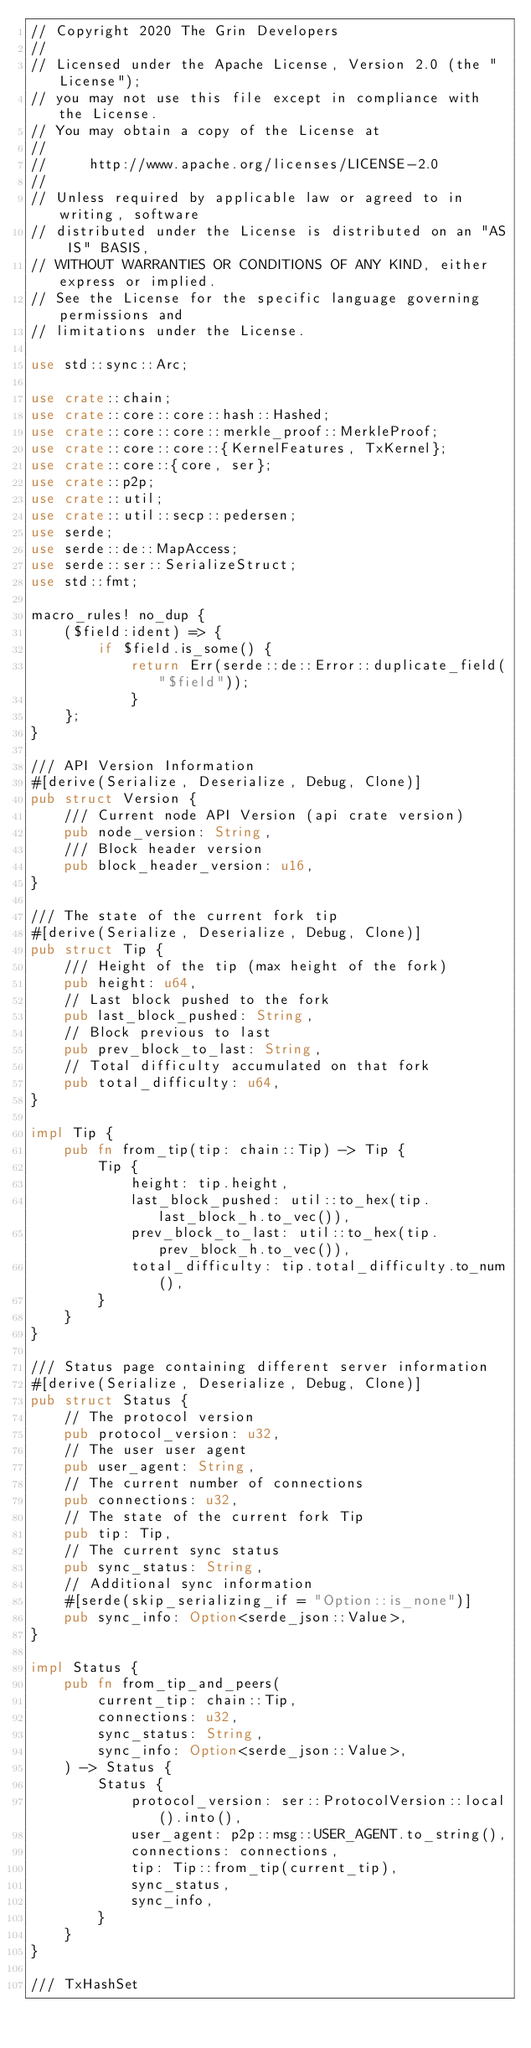Convert code to text. <code><loc_0><loc_0><loc_500><loc_500><_Rust_>// Copyright 2020 The Grin Developers
//
// Licensed under the Apache License, Version 2.0 (the "License");
// you may not use this file except in compliance with the License.
// You may obtain a copy of the License at
//
//     http://www.apache.org/licenses/LICENSE-2.0
//
// Unless required by applicable law or agreed to in writing, software
// distributed under the License is distributed on an "AS IS" BASIS,
// WITHOUT WARRANTIES OR CONDITIONS OF ANY KIND, either express or implied.
// See the License for the specific language governing permissions and
// limitations under the License.

use std::sync::Arc;

use crate::chain;
use crate::core::core::hash::Hashed;
use crate::core::core::merkle_proof::MerkleProof;
use crate::core::core::{KernelFeatures, TxKernel};
use crate::core::{core, ser};
use crate::p2p;
use crate::util;
use crate::util::secp::pedersen;
use serde;
use serde::de::MapAccess;
use serde::ser::SerializeStruct;
use std::fmt;

macro_rules! no_dup {
	($field:ident) => {
		if $field.is_some() {
			return Err(serde::de::Error::duplicate_field("$field"));
			}
	};
}

/// API Version Information
#[derive(Serialize, Deserialize, Debug, Clone)]
pub struct Version {
	/// Current node API Version (api crate version)
	pub node_version: String,
	/// Block header version
	pub block_header_version: u16,
}

/// The state of the current fork tip
#[derive(Serialize, Deserialize, Debug, Clone)]
pub struct Tip {
	/// Height of the tip (max height of the fork)
	pub height: u64,
	// Last block pushed to the fork
	pub last_block_pushed: String,
	// Block previous to last
	pub prev_block_to_last: String,
	// Total difficulty accumulated on that fork
	pub total_difficulty: u64,
}

impl Tip {
	pub fn from_tip(tip: chain::Tip) -> Tip {
		Tip {
			height: tip.height,
			last_block_pushed: util::to_hex(tip.last_block_h.to_vec()),
			prev_block_to_last: util::to_hex(tip.prev_block_h.to_vec()),
			total_difficulty: tip.total_difficulty.to_num(),
		}
	}
}

/// Status page containing different server information
#[derive(Serialize, Deserialize, Debug, Clone)]
pub struct Status {
	// The protocol version
	pub protocol_version: u32,
	// The user user agent
	pub user_agent: String,
	// The current number of connections
	pub connections: u32,
	// The state of the current fork Tip
	pub tip: Tip,
	// The current sync status
	pub sync_status: String,
	// Additional sync information
	#[serde(skip_serializing_if = "Option::is_none")]
	pub sync_info: Option<serde_json::Value>,
}

impl Status {
	pub fn from_tip_and_peers(
		current_tip: chain::Tip,
		connections: u32,
		sync_status: String,
		sync_info: Option<serde_json::Value>,
	) -> Status {
		Status {
			protocol_version: ser::ProtocolVersion::local().into(),
			user_agent: p2p::msg::USER_AGENT.to_string(),
			connections: connections,
			tip: Tip::from_tip(current_tip),
			sync_status,
			sync_info,
		}
	}
}

/// TxHashSet</code> 